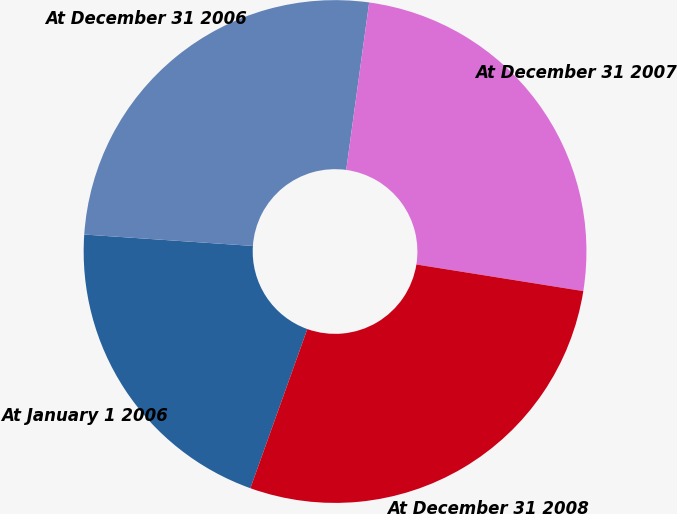Convert chart. <chart><loc_0><loc_0><loc_500><loc_500><pie_chart><fcel>At January 1 2006<fcel>At December 31 2006<fcel>At December 31 2007<fcel>At December 31 2008<nl><fcel>20.61%<fcel>26.09%<fcel>25.35%<fcel>27.95%<nl></chart> 